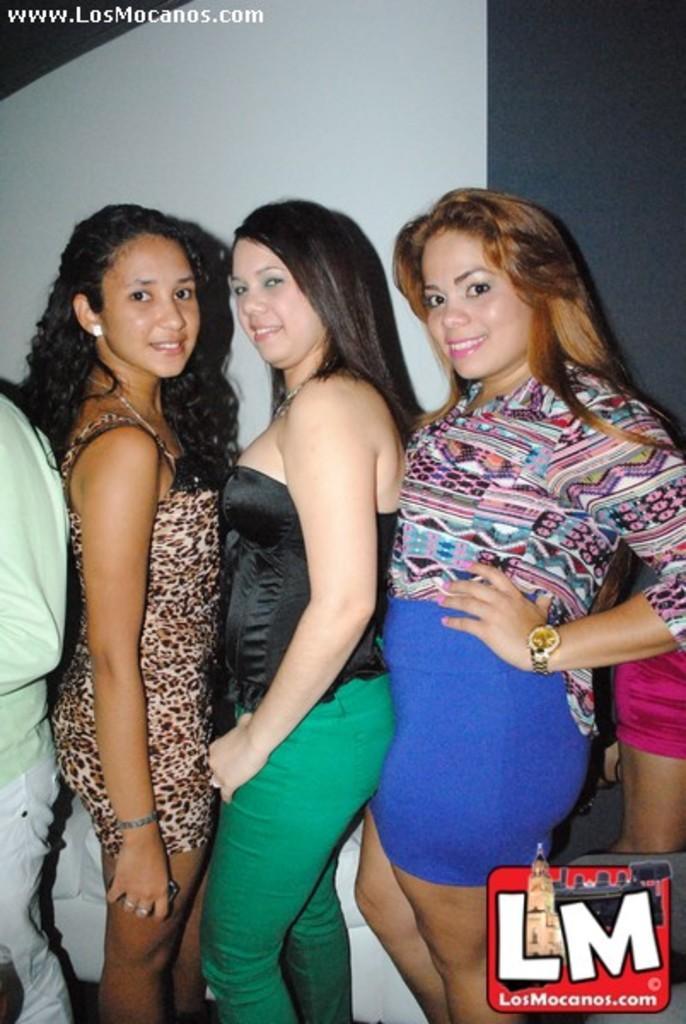How would you summarize this image in a sentence or two? This picture shows three women standing with a smile on their faces and we see people standing on the either side and we see a wall. 